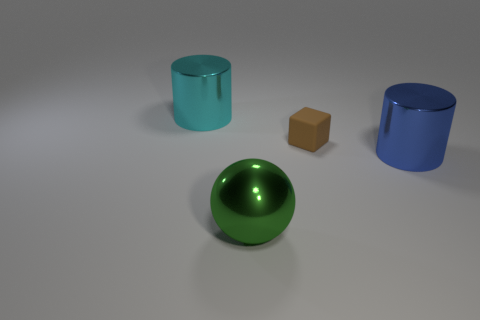Is there any other thing that has the same size as the rubber object?
Provide a succinct answer. No. Are there any other things that have the same material as the ball?
Keep it short and to the point. Yes. There is a large cylinder that is in front of the big object on the left side of the green object; is there a big cyan shiny object that is on the right side of it?
Your answer should be compact. No. There is a big thing that is in front of the blue thing; what is its material?
Your response must be concise. Metal. What number of small things are yellow rubber cylinders or green metal balls?
Your answer should be very brief. 0. Does the cylinder that is in front of the cyan metal cylinder have the same size as the big cyan shiny cylinder?
Ensure brevity in your answer.  Yes. What is the big cyan cylinder made of?
Give a very brief answer. Metal. There is a big object that is both left of the small brown matte cube and in front of the large cyan cylinder; what is it made of?
Your answer should be compact. Metal. What number of objects are either cylinders that are in front of the tiny brown cube or big blue metallic things?
Provide a short and direct response. 1. Is the large sphere the same color as the small rubber block?
Provide a short and direct response. No. 